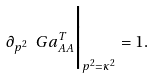Convert formula to latex. <formula><loc_0><loc_0><loc_500><loc_500>\partial _ { p ^ { 2 } } \ G a ^ { T } _ { A A } \Big | _ { p ^ { 2 } = \kappa ^ { 2 } } = 1 \/ .</formula> 